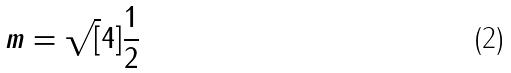<formula> <loc_0><loc_0><loc_500><loc_500>m = \sqrt { [ } 4 ] { \frac { 1 } { 2 } }</formula> 